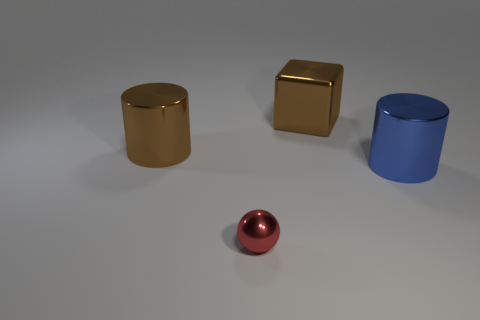Add 3 small red shiny cylinders. How many objects exist? 7 Subtract all cubes. How many objects are left? 3 Subtract all blue rubber things. Subtract all big things. How many objects are left? 1 Add 1 big brown cylinders. How many big brown cylinders are left? 2 Add 1 big red matte objects. How many big red matte objects exist? 1 Subtract 0 yellow balls. How many objects are left? 4 